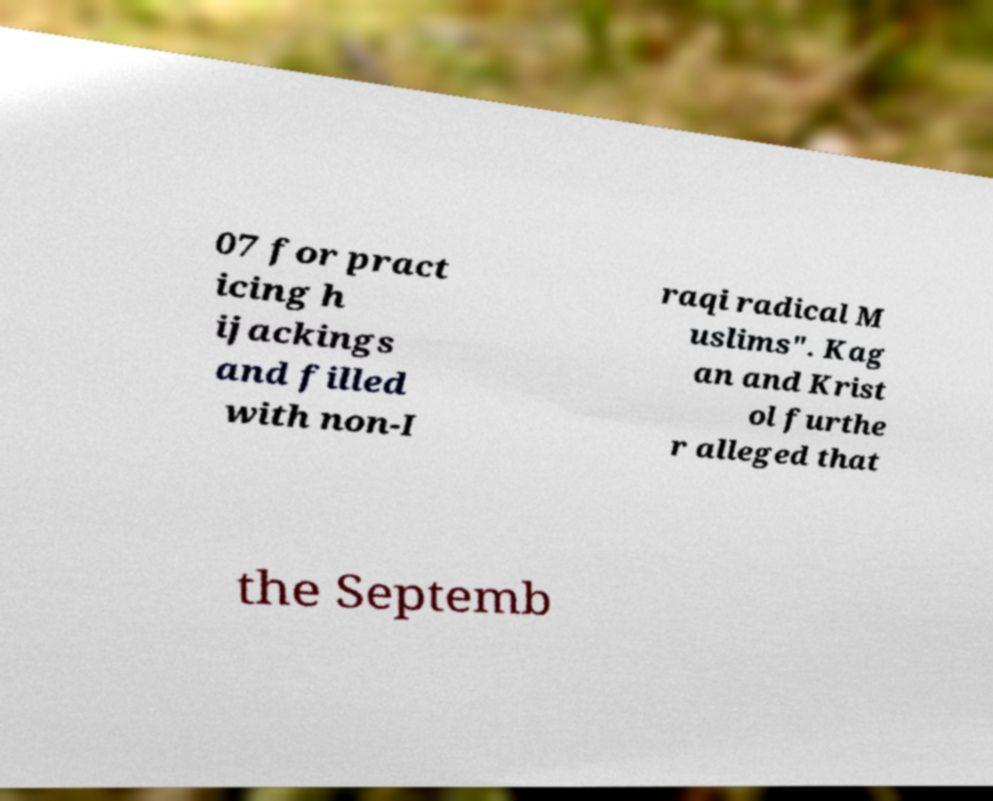Please identify and transcribe the text found in this image. 07 for pract icing h ijackings and filled with non-I raqi radical M uslims". Kag an and Krist ol furthe r alleged that the Septemb 